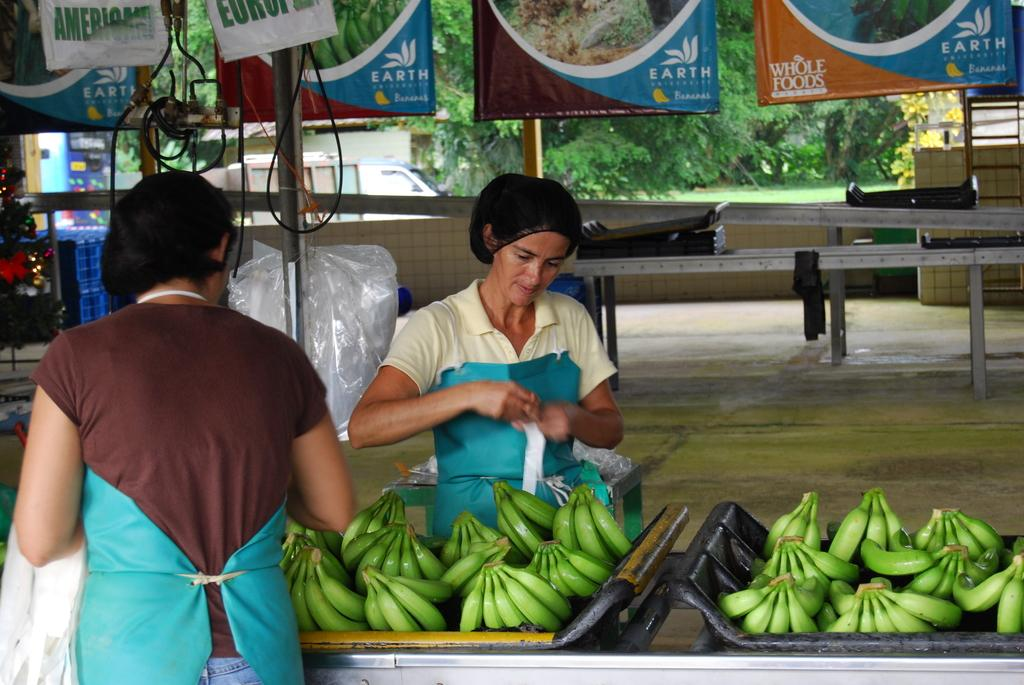How many people are in the image? There are two persons standing in the image. What is on the trays that the people are holding? There are bananas on the trays. What structures can be seen in the image? There are poles in the image. What decorative elements are present in the image? There are banners in the image. What utility elements are visible in the image? There are cables in the image. What type of natural elements can be seen in the image? There are trees in the image. What mode of transportation is present in the image? There is a vehicle in the image. What other objects can be seen in the image? There are some other objects in the image. How many dolls are sitting on the vehicle in the image? There are no dolls present in the image; it only shows two persons standing, bananas on trays, poles, banners, cables, trees, and other objects. 